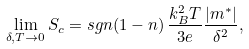Convert formula to latex. <formula><loc_0><loc_0><loc_500><loc_500>\lim _ { \delta , T \rightarrow 0 } S _ { c } = s g n ( 1 - n ) \, \frac { k _ { B } ^ { 2 } T } { 3 e } \frac { | m ^ { \ast } | } { \delta ^ { 2 } } ,</formula> 